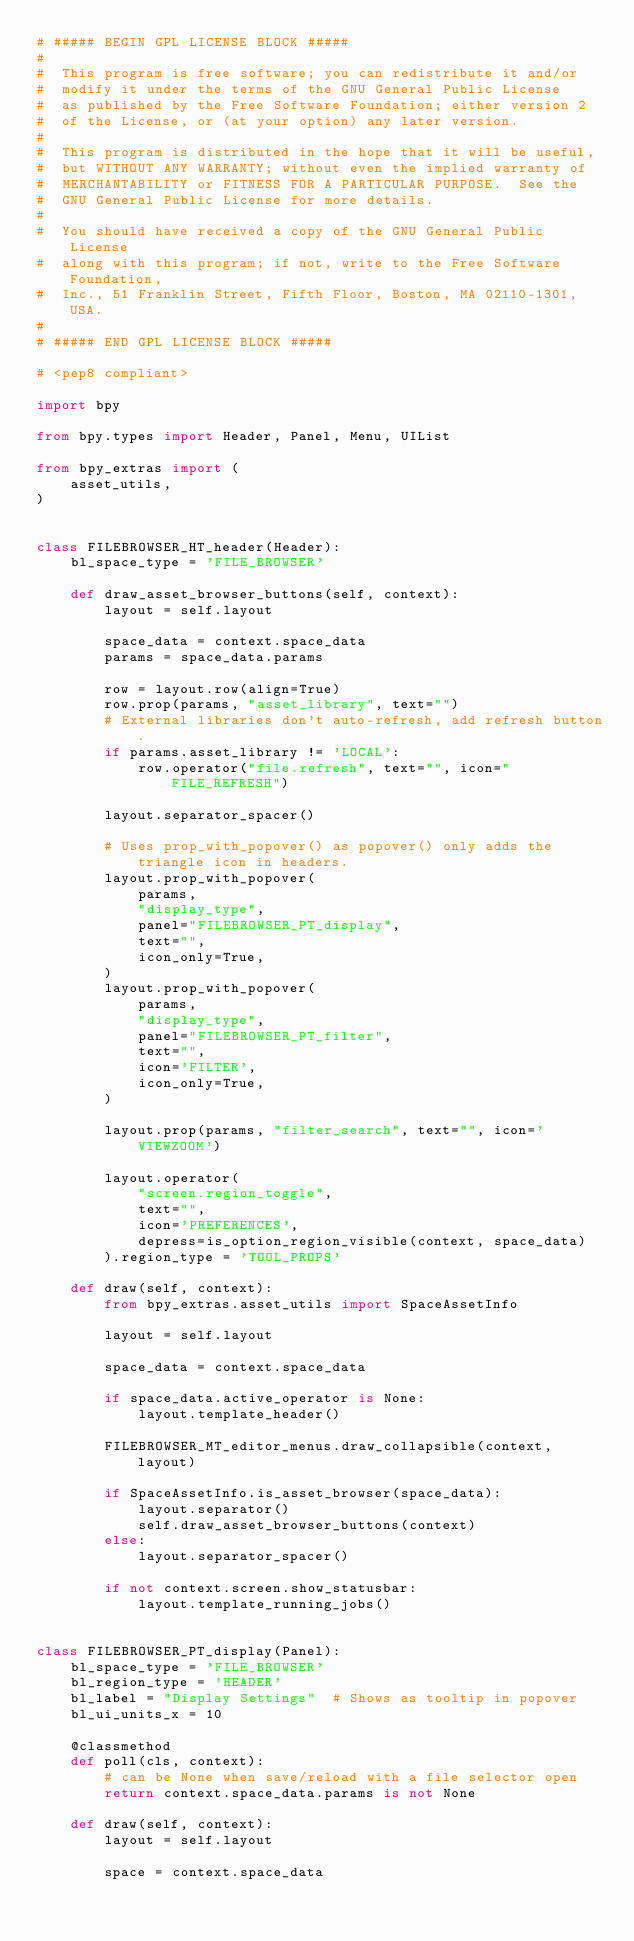<code> <loc_0><loc_0><loc_500><loc_500><_Python_># ##### BEGIN GPL LICENSE BLOCK #####
#
#  This program is free software; you can redistribute it and/or
#  modify it under the terms of the GNU General Public License
#  as published by the Free Software Foundation; either version 2
#  of the License, or (at your option) any later version.
#
#  This program is distributed in the hope that it will be useful,
#  but WITHOUT ANY WARRANTY; without even the implied warranty of
#  MERCHANTABILITY or FITNESS FOR A PARTICULAR PURPOSE.  See the
#  GNU General Public License for more details.
#
#  You should have received a copy of the GNU General Public License
#  along with this program; if not, write to the Free Software Foundation,
#  Inc., 51 Franklin Street, Fifth Floor, Boston, MA 02110-1301, USA.
#
# ##### END GPL LICENSE BLOCK #####

# <pep8 compliant>

import bpy

from bpy.types import Header, Panel, Menu, UIList

from bpy_extras import (
    asset_utils,
)


class FILEBROWSER_HT_header(Header):
    bl_space_type = 'FILE_BROWSER'

    def draw_asset_browser_buttons(self, context):
        layout = self.layout

        space_data = context.space_data
        params = space_data.params

        row = layout.row(align=True)
        row.prop(params, "asset_library", text="")
        # External libraries don't auto-refresh, add refresh button.
        if params.asset_library != 'LOCAL':
            row.operator("file.refresh", text="", icon="FILE_REFRESH")

        layout.separator_spacer()

        # Uses prop_with_popover() as popover() only adds the triangle icon in headers.
        layout.prop_with_popover(
            params,
            "display_type",
            panel="FILEBROWSER_PT_display",
            text="",
            icon_only=True,
        )
        layout.prop_with_popover(
            params,
            "display_type",
            panel="FILEBROWSER_PT_filter",
            text="",
            icon='FILTER',
            icon_only=True,
        )

        layout.prop(params, "filter_search", text="", icon='VIEWZOOM')

        layout.operator(
            "screen.region_toggle",
            text="",
            icon='PREFERENCES',
            depress=is_option_region_visible(context, space_data)
        ).region_type = 'TOOL_PROPS'

    def draw(self, context):
        from bpy_extras.asset_utils import SpaceAssetInfo

        layout = self.layout

        space_data = context.space_data

        if space_data.active_operator is None:
            layout.template_header()

        FILEBROWSER_MT_editor_menus.draw_collapsible(context, layout)

        if SpaceAssetInfo.is_asset_browser(space_data):
            layout.separator()
            self.draw_asset_browser_buttons(context)
        else:
            layout.separator_spacer()

        if not context.screen.show_statusbar:
            layout.template_running_jobs()


class FILEBROWSER_PT_display(Panel):
    bl_space_type = 'FILE_BROWSER'
    bl_region_type = 'HEADER'
    bl_label = "Display Settings"  # Shows as tooltip in popover
    bl_ui_units_x = 10

    @classmethod
    def poll(cls, context):
        # can be None when save/reload with a file selector open
        return context.space_data.params is not None

    def draw(self, context):
        layout = self.layout

        space = context.space_data</code> 